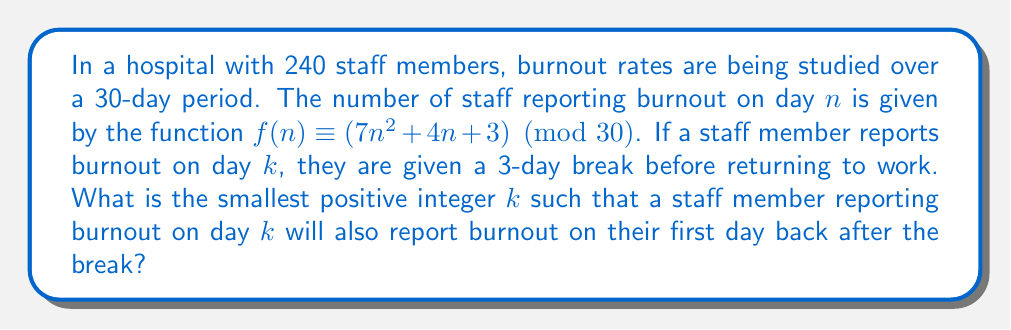What is the answer to this math problem? Let's approach this step-by-step:

1) A staff member reporting burnout on day $k$ will return to work on day $k+3$.

2) We need to find the smallest positive $k$ where $f(k) \equiv f(k+3) \pmod{30}$.

3) Let's expand this equation:
   $$(7k^2 + 4k + 3) \equiv (7(k+3)^2 + 4(k+3) + 3) \pmod{30}$$

4) Expand the right side:
   $$(7k^2 + 4k + 3) \equiv (7k^2 + 42k + 63 + 4k + 12 + 3) \pmod{30}$$
   $$(7k^2 + 4k + 3) \equiv (7k^2 + 46k + 78) \pmod{30}$$

5) Subtract the left side from both sides:
   $$0 \equiv (42k + 75) \pmod{30}$$

6) Simplify:
   $$0 \equiv (12k + 15) \pmod{30}$$

7) Subtract 15 from both sides:
   $$-15 \equiv 12k \pmod{30}$$

8) Multiply both sides by 5 (since $5 \cdot 12 \equiv 0 \pmod{30}$):
   $$-75 \equiv 60k \pmod{30}$$
   $$15 \equiv 0k \pmod{30}$$

9) This is true for all $k$. However, we need the smallest positive $k$.

10) The smallest positive $k$ that satisfies this is $k=1$, as $f(1) \equiv f(4) \pmod{30}$.

   $f(1) = 7(1)^2 + 4(1) + 3 = 14 \pmod{30}$
   $f(4) = 7(4)^2 + 4(4) + 3 = 131 \equiv 14 \pmod{30}$
Answer: $1$ 